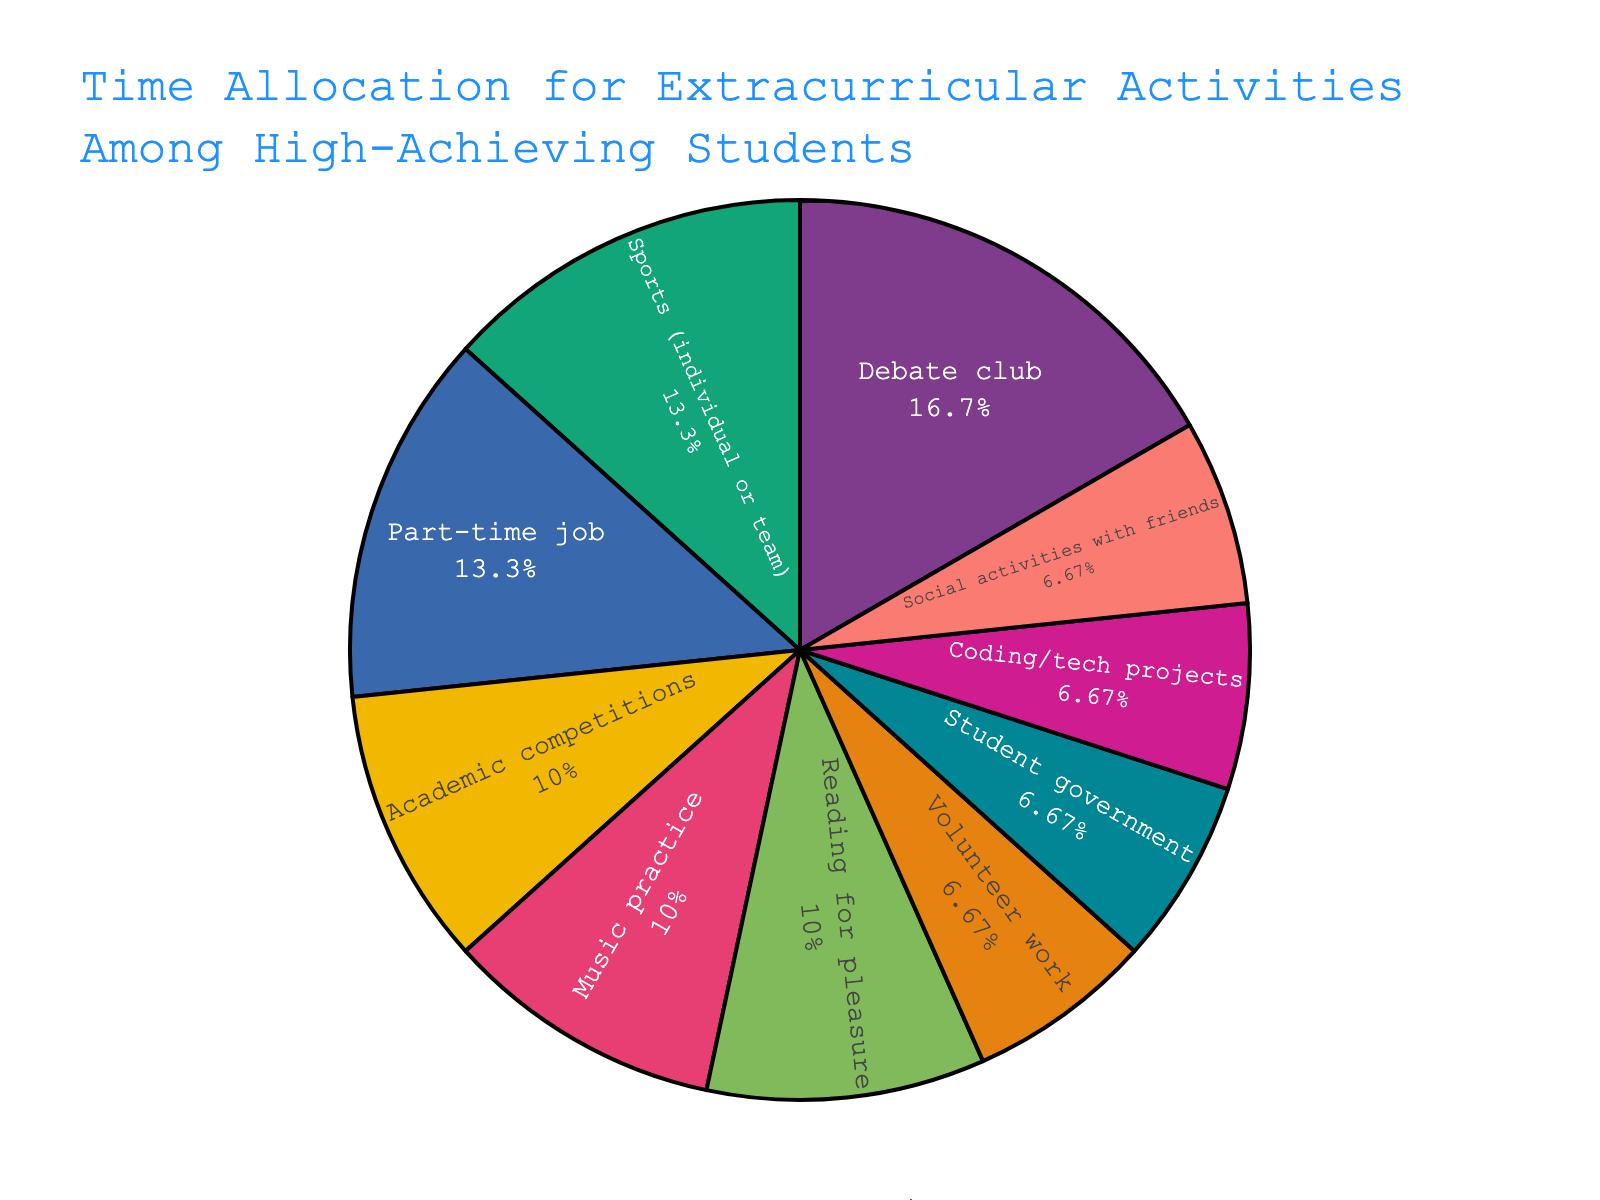What's the total amount of time spent on sports and music practice per week? The figure shows the hours per week for each activity. Add the hours for sports (4 hours) and music practice (3 hours): 4 + 3 = 7 hours.
Answer: 7 hours What's the largest single time allocation among the activities? Look at the figure and identify the activity with the largest portion of the pie chart. The largest allocation is Debate club with 5 hours.
Answer: Debate club What percentage of the total weekly hours is spent on social activities with friends and student government combined? First, calculate the total hours for these activities: Social activities (2) + Student government (2) = 4 hours. Then, calculate the percentage: (4 / 30) * 100 = 13.33%.
Answer: 13.33% Is more time spent on academic competitions or coding/tech projects? Compare the hours spent on academic competitions (3 hours) with that spent on coding/tech projects (2 hours). 3 is greater than 2.
Answer: Academic competitions Which activity's time allocation is closest to the weekly average hours spent on all activities? Calculate the average weekly hours: Total hours (30) / Number of activities (10) = 3 hours. Find the activity with 3 hours: Academic competitions, Music practice, Reading for pleasure.
Answer: Academic competitions, Music practice, Reading for pleasure What is the ratio of time spent on volunteer work to the time spent on sports? The pie chart shows 2 hours for volunteer work and 4 hours for sports. The ratio is 2:4, which simplifies to 1:2.
Answer: 1:2 Which two activities together make up approximately a quarter of the total weekly hours? Look for activities whose combined hours are approximately 7.5, which is a quarter of 30. Studies hours for Part-time job (4) and Reading for pleasure (3): 4 + 3 = 7 hours.
Answer: Part-time job and Reading for pleasure How does the time spent on a part-time job compare to the time spent on all academic-related activities combined? First, get the hours for academic-related activities: Debate club (5) + Academic competitions (3) = 8 hours. Part-time job is 4 hours. Compare 8 to 4. 8 is greater than 4.
Answer: The combined academic-related activities What visual feature indicates the distribution of time across different activities most clearly? The pie chart's segments and their varying sizes represent the distribution of time, with larger segments indicating more time spent on those activities. The colors help differentiate each segment.
Answer: Pie chart segments 